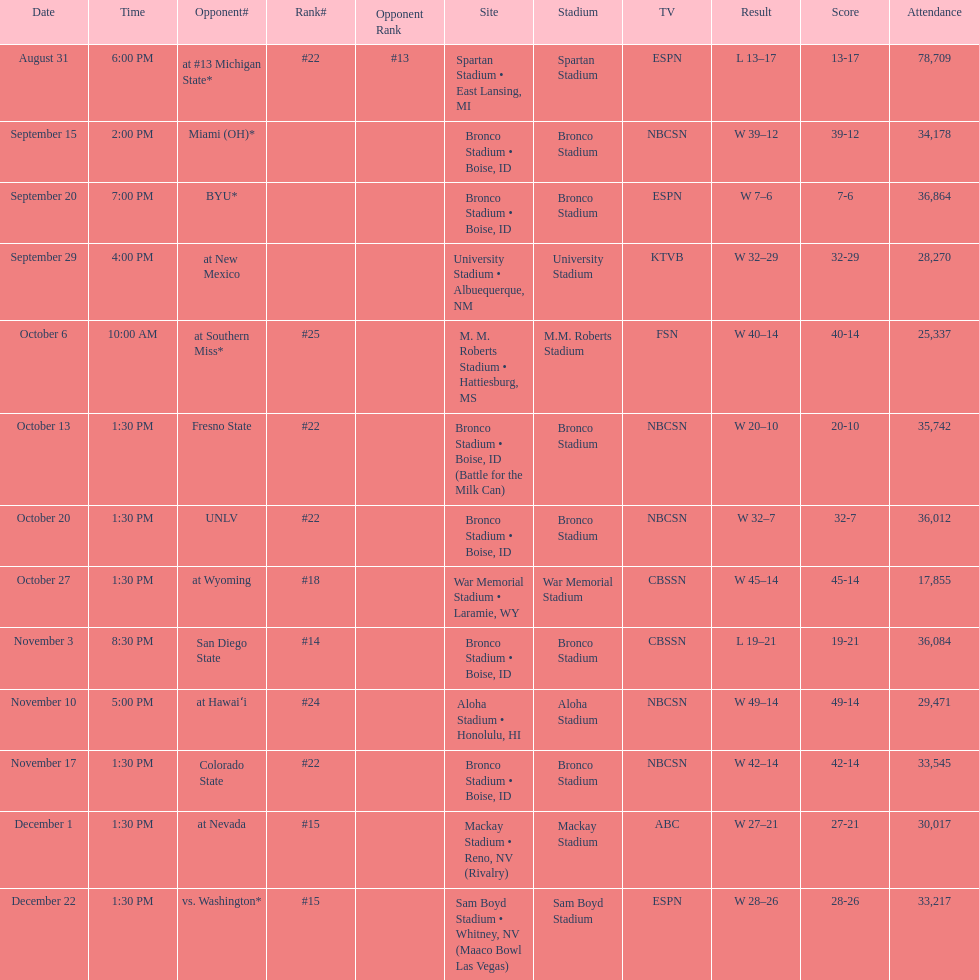Calculate the total sum of points achieved in the recent victories for boise state. 146. Write the full table. {'header': ['Date', 'Time', 'Opponent#', 'Rank#', 'Opponent Rank', 'Site', 'Stadium', 'TV', 'Result', 'Score', 'Attendance'], 'rows': [['August 31', '6:00 PM', 'at\xa0#13\xa0Michigan State*', '#22', '#13', 'Spartan Stadium • East Lansing, MI', 'Spartan Stadium', 'ESPN', 'L\xa013–17', '13-17', '78,709'], ['September 15', '2:00 PM', 'Miami (OH)*', '', '', 'Bronco Stadium • Boise, ID', 'Bronco Stadium', 'NBCSN', 'W\xa039–12', '39-12', '34,178'], ['September 20', '7:00 PM', 'BYU*', '', '', 'Bronco Stadium • Boise, ID', 'Bronco Stadium', 'ESPN', 'W\xa07–6', '7-6', '36,864'], ['September 29', '4:00 PM', 'at\xa0New Mexico', '', '', 'University Stadium • Albuequerque, NM', 'University Stadium', 'KTVB', 'W\xa032–29', '32-29', '28,270'], ['October 6', '10:00 AM', 'at\xa0Southern Miss*', '#25', '', 'M. M. Roberts Stadium • Hattiesburg, MS', 'M.M. Roberts Stadium', 'FSN', 'W\xa040–14', '40-14', '25,337'], ['October 13', '1:30 PM', 'Fresno State', '#22', '', 'Bronco Stadium • Boise, ID (Battle for the Milk Can)', 'Bronco Stadium', 'NBCSN', 'W\xa020–10', '20-10', '35,742'], ['October 20', '1:30 PM', 'UNLV', '#22', '', 'Bronco Stadium • Boise, ID', 'Bronco Stadium', 'NBCSN', 'W\xa032–7', '32-7', '36,012'], ['October 27', '1:30 PM', 'at\xa0Wyoming', '#18', '', 'War Memorial Stadium • Laramie, WY', 'War Memorial Stadium', 'CBSSN', 'W\xa045–14', '45-14', '17,855'], ['November 3', '8:30 PM', 'San Diego State', '#14', '', 'Bronco Stadium • Boise, ID', 'Bronco Stadium', 'CBSSN', 'L\xa019–21', '19-21', '36,084'], ['November 10', '5:00 PM', 'at\xa0Hawaiʻi', '#24', '', 'Aloha Stadium • Honolulu, HI', 'Aloha Stadium', 'NBCSN', 'W\xa049–14', '49-14', '29,471'], ['November 17', '1:30 PM', 'Colorado State', '#22', '', 'Bronco Stadium • Boise, ID', 'Bronco Stadium', 'NBCSN', 'W\xa042–14', '42-14', '33,545'], ['December 1', '1:30 PM', 'at\xa0Nevada', '#15', '', 'Mackay Stadium • Reno, NV (Rivalry)', 'Mackay Stadium', 'ABC', 'W\xa027–21', '27-21', '30,017'], ['December 22', '1:30 PM', 'vs.\xa0Washington*', '#15', '', 'Sam Boyd Stadium • Whitney, NV (Maaco Bowl Las Vegas)', 'Sam Boyd Stadium', 'ESPN', 'W\xa028–26', '28-26', '33,217']]} 